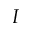Convert formula to latex. <formula><loc_0><loc_0><loc_500><loc_500>I</formula> 